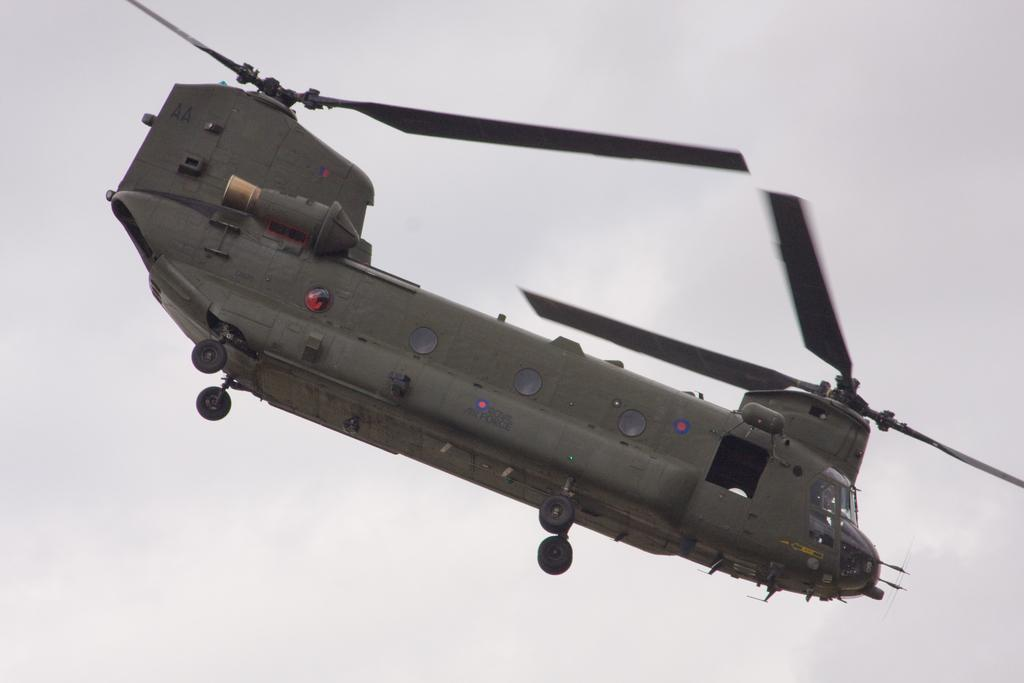What is the main subject of the image? The main subject of the image is an airplane. What is the airplane doing in the image? The airplane is flying in the air. What color is the background of the image? The background of the image is white. How many eggs are visible on the roof in the image? There are no eggs or roof present in the image; it features an airplane flying in the air with a white background. 